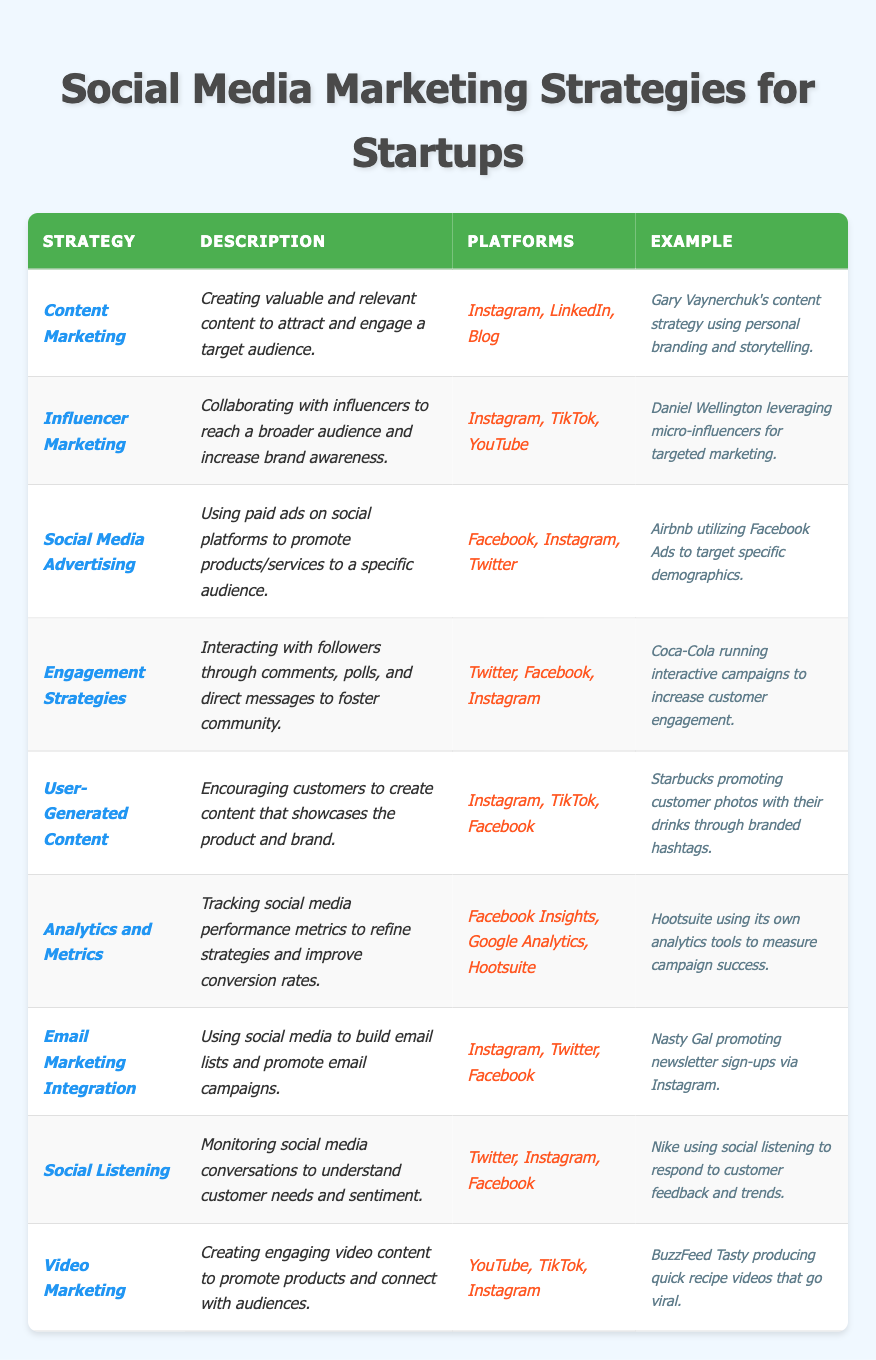What is the description of the "User-Generated Content" strategy? The table indicates that the description for "User-Generated Content" is "Encouraging customers to create content that showcases the product and brand."
Answer: Encouraging customers to create content that showcases the product and brand Which platforms are used for Video Marketing? Referring to the table, the platforms listed for Video Marketing are "YouTube, TikTok, Instagram."
Answer: YouTube, TikTok, Instagram How many different strategies involve Instagram as a platform? By counting the occurrences in the table, Instagram appears in the following strategies: Content Marketing, Influencer Marketing, Social Media Advertising, Engagement Strategies, User-Generated Content, Email Marketing Integration, Social Listening, and Video Marketing. That's a total of 8 strategies.
Answer: 8 Is "Analytics and Metrics" strategy associated with TikTok? Looking at the table, TikTok is not mentioned as a platform for the "Analytics and Metrics" strategy. It lists Facebook Insights, Google Analytics, and Hootsuite.
Answer: No Which strategy has Coca-Cola as an example? The strategy that lists Coca-Cola as an example in the table is "Engagement Strategies."
Answer: Engagement Strategies What is the relationship between Social Listening and the platforms it uses? The table shows that the "Social Listening" strategy utilizes Twitter, Instagram, and Facebook, which are all platforms that allow monitoring social media conversations. This indicates a direct relationship as these platforms facilitate social listening activities.
Answer: They support monitoring social media conversations Can you name one startup that effectively utilizes micro-influencers according to the table? The table states that Daniel Wellington is an example of a startup leveraging micro-influencers for targeted marketing.
Answer: Daniel Wellington If a startup uses both User-Generated Content and Email Marketing Integration, how many unique platforms are involved? User-Generated Content utilizes Instagram, TikTok, Facebook, while Email Marketing Integration uses Instagram, Twitter, and Facebook. Counting all unique platforms: Instagram, TikTok, Facebook, and Twitter gives a total of 4 unique platforms.
Answer: 4 unique platforms What type of content strategy does Gary Vaynerchuk primarily use? The table states that Gary Vaynerchuk's content strategy is focused on "Personal branding and storytelling," and it falls under the "Content Marketing" strategy.
Answer: Personal branding and storytelling How can Hootsuite measure its campaign success? According to the table, Hootsuite uses its own analytics tools, such as Facebook Insights and Google Analytics, to track social media performance metrics. This helps in refining strategies and improving conversion rates.
Answer: By using its analytics tools 